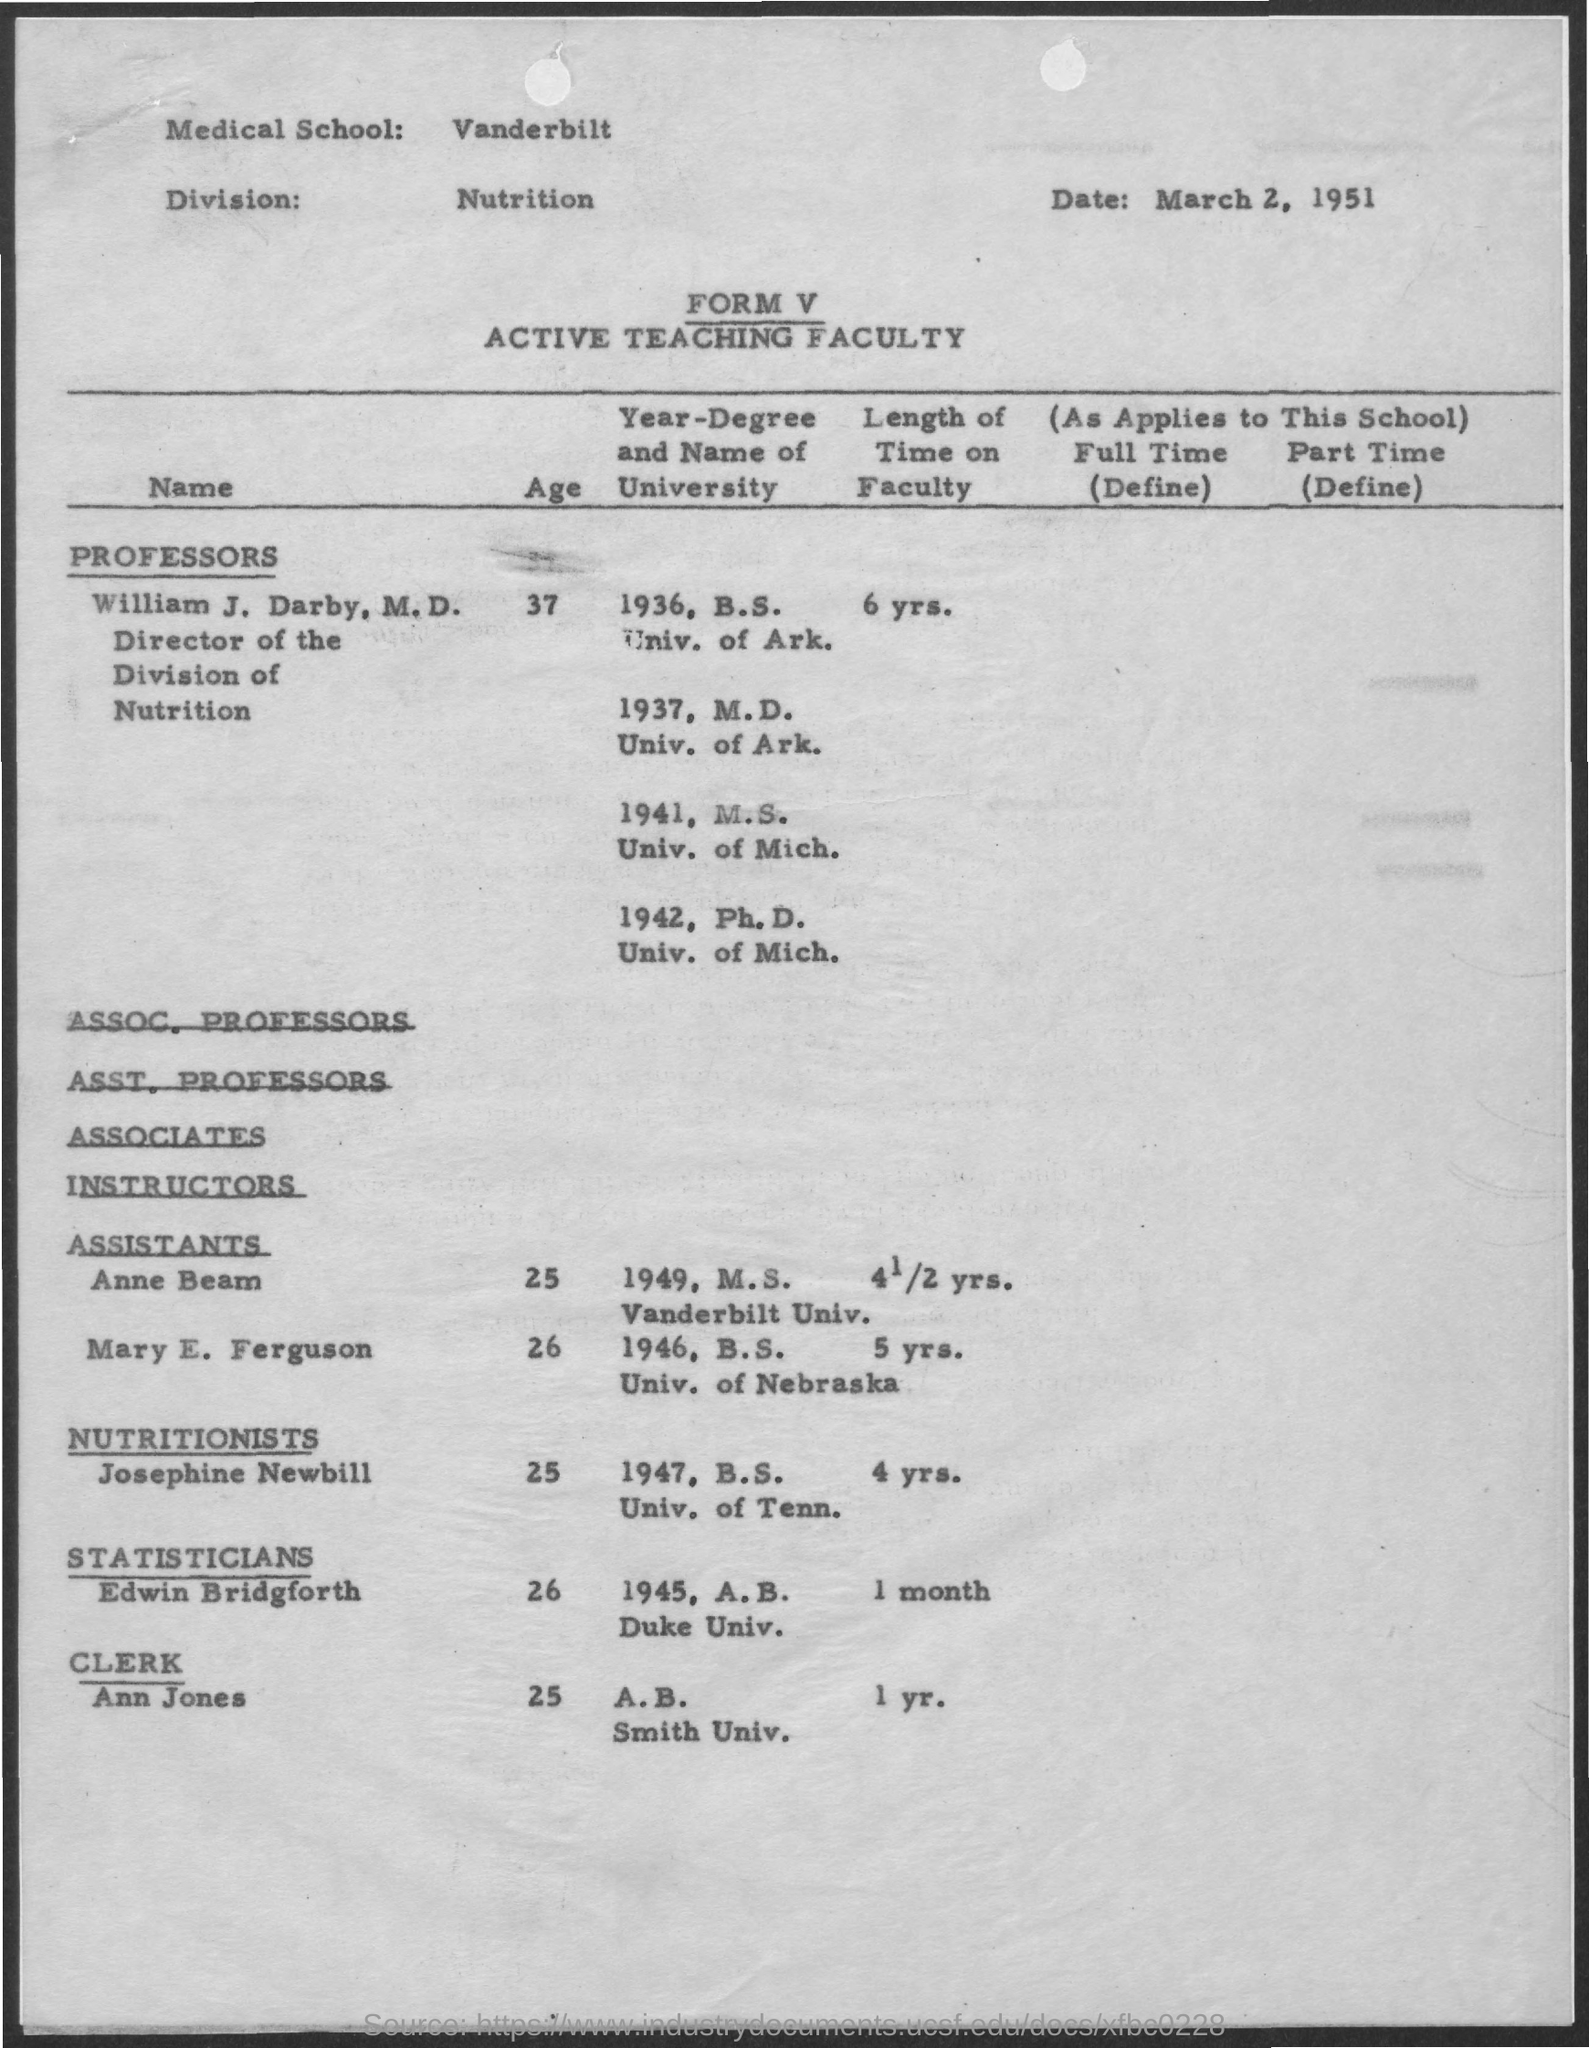Indicate a few pertinent items in this graphic. Ann Jones is 25 years old. The age of Josephine Newbill is 25 years old. Ann Jones has been on the faculty for one year. Edwin Bridgforth is 26 years old. The date mentioned is March 2, 1951. 